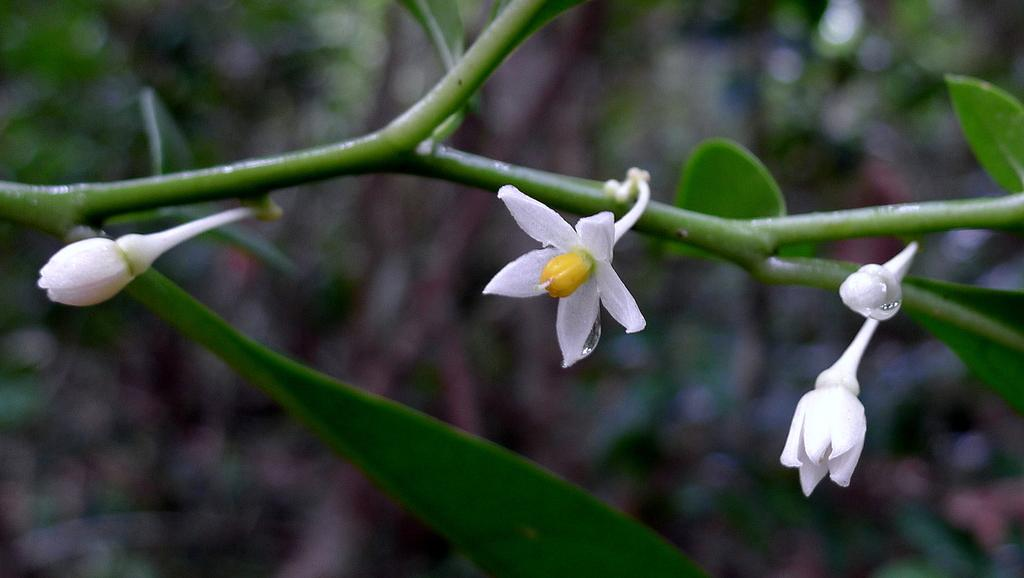What is present in the foreground of the picture? There are flowers, leaves, and a stem of a plant in the foreground of the picture. What color is the background of the image? The background of the image is green. Can you see any steam coming from the flowers in the image? There is no steam present in the image; it features flowers, leaves, and a stem of a plant in the foreground. What type of development can be seen in the background of the image? There is no development visible in the image; it features a green background. 